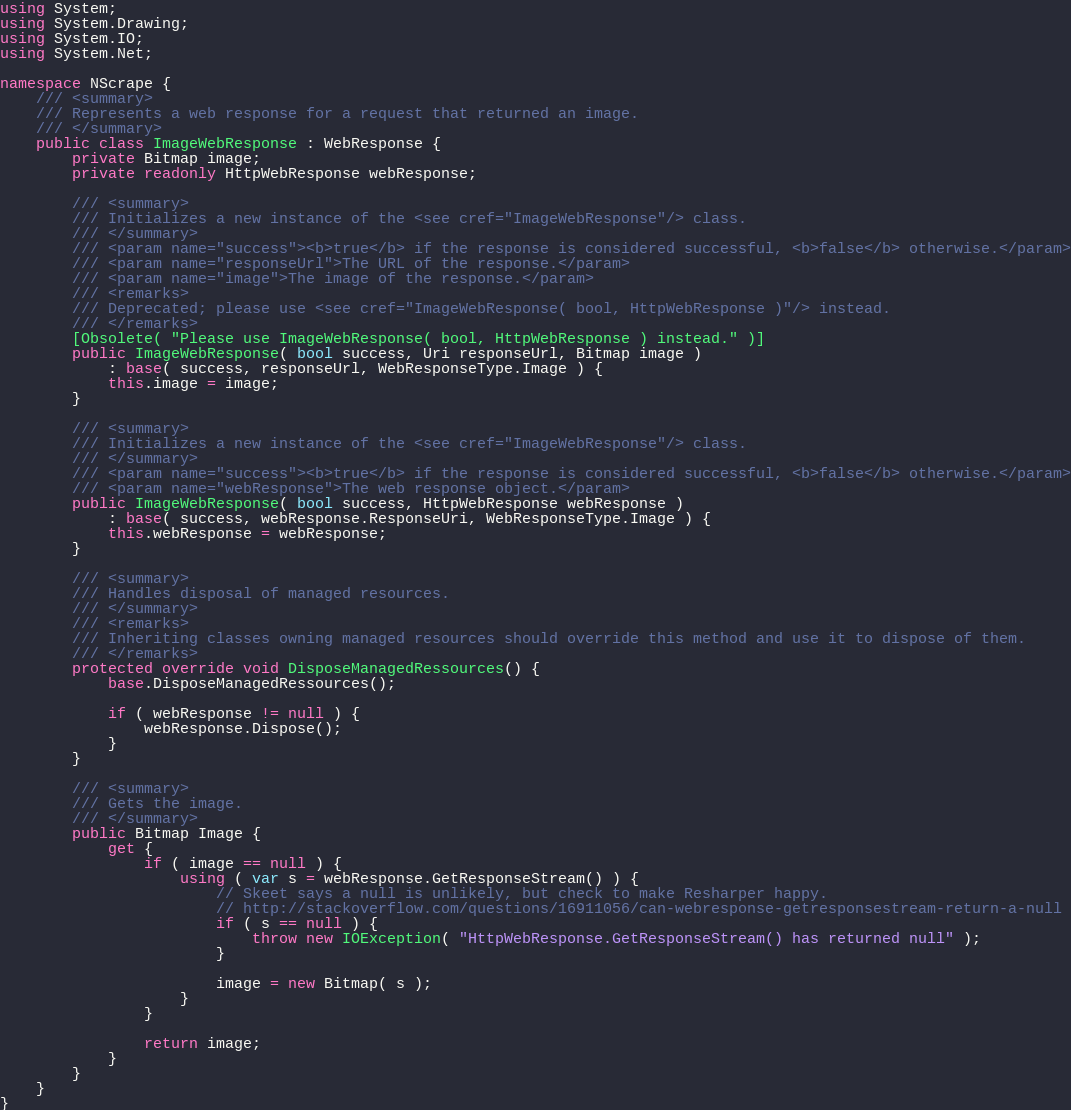<code> <loc_0><loc_0><loc_500><loc_500><_C#_>using System;
using System.Drawing;
using System.IO;
using System.Net;

namespace NScrape {
    /// <summary>
	/// Represents a web response for a request that returned an image.
	/// </summary>
    public class ImageWebResponse : WebResponse {
        private Bitmap image;
		private readonly HttpWebResponse webResponse;

	    /// <summary>
	    /// Initializes a new instance of the <see cref="ImageWebResponse"/> class.
	    /// </summary>
	    /// <param name="success"><b>true</b> if the response is considered successful, <b>false</b> otherwise.</param>
	    /// <param name="responseUrl">The URL of the response.</param>
	    /// <param name="image">The image of the response.</param>
		/// <remarks>
		/// Deprecated; please use <see cref="ImageWebResponse( bool, HttpWebResponse )"/> instead.
		/// </remarks>
		[Obsolete( "Please use ImageWebResponse( bool, HttpWebResponse ) instead." )]
		public ImageWebResponse( bool success, Uri responseUrl, Bitmap image )
            : base( success, responseUrl, WebResponseType.Image ) {
            this.image = image;
        }

		/// <summary>
		/// Initializes a new instance of the <see cref="ImageWebResponse"/> class.
		/// </summary>
		/// <param name="success"><b>true</b> if the response is considered successful, <b>false</b> otherwise.</param>
		/// <param name="webResponse">The web response object.</param>
		public ImageWebResponse( bool success, HttpWebResponse webResponse )
			: base( success, webResponse.ResponseUri, WebResponseType.Image ) {
			this.webResponse = webResponse;
		}

		/// <summary>
		/// Handles disposal of managed resources.
		/// </summary>
		/// <remarks>
		/// Inheriting classes owning managed resources should override this method and use it to dispose of them.
		/// </remarks>
		protected override void DisposeManagedRessources() {
			base.DisposeManagedRessources();

			if ( webResponse != null ) {
				webResponse.Dispose();
			}
		}

	    /// <summary>
		/// Gets the image.
		/// </summary>
		public Bitmap Image {
			get {
				if ( image == null ) {
					using ( var s = webResponse.GetResponseStream() ) {
						// Skeet says a null is unlikely, but check to make Resharper happy.
						// http://stackoverflow.com/questions/16911056/can-webresponse-getresponsestream-return-a-null
						if ( s == null ) {
							throw new IOException( "HttpWebResponse.GetResponseStream() has returned null" );
						}

						image = new Bitmap( s );
					}
				}

				return image;
			}
		}
    }
}
</code> 